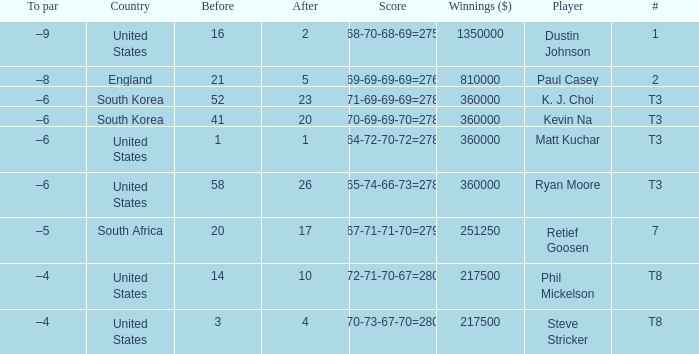How many times is  a to par listed when the player is phil mickelson? 1.0. 